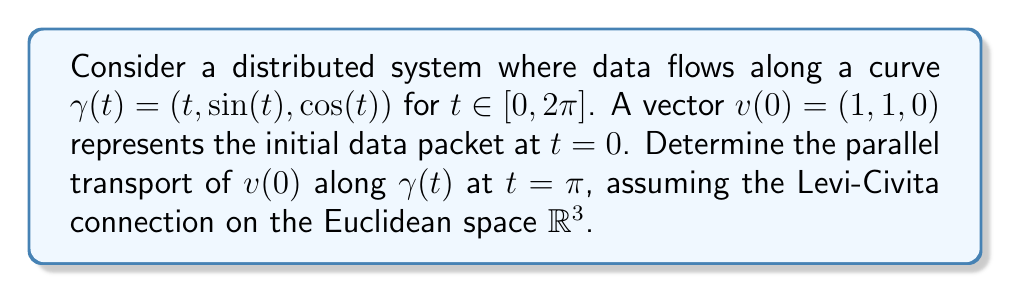Could you help me with this problem? To solve this problem, we'll follow these steps:

1) The parallel transport equation for a vector $v(t)$ along a curve $\gamma(t)$ is given by:

   $$\frac{Dv}{dt} = \nabla_{\dot{\gamma}}v = 0$$

2) In Euclidean space with the Levi-Civita connection, this simplifies to:

   $$\frac{dv}{dt} = 0$$

3) This means that the components of $v(t)$ remain constant along the curve. Therefore:

   $$v(t) = v(0) = (1, 1, 0)$$

4) The parallel transport preserves the vector's magnitude and its angle with the curve's tangent vector.

5) At $t = \pi$, the point on the curve is:

   $$\gamma(\pi) = (\pi, \sin(\pi), \cos(\pi)) = (\pi, 0, -1)$$

6) The tangent vector at this point is:

   $$\dot{\gamma}(\pi) = (1, \cos(\pi), -\sin(\pi)) = (1, -1, 0)$$

7) We can verify that the angle between $v(\pi)$ and $\dot{\gamma}(\pi)$ is the same as the angle between $v(0)$ and $\dot{\gamma}(0)$:

   At $t=0$: $\cos\theta = \frac{v(0) \cdot \dot{\gamma}(0)}{|v(0)| |\dot{\gamma}(0)|} = \frac{1}{\sqrt{2}}$
   
   At $t=\pi$: $\cos\theta = \frac{v(\pi) \cdot \dot{\gamma}(\pi)}{|v(\pi)| |\dot{\gamma}(\pi)|} = \frac{1}{\sqrt{2}}$

Therefore, the parallel transport of $v(0)$ along $\gamma(t)$ at $t = \pi$ is $(1, 1, 0)$.
Answer: $(1, 1, 0)$ 